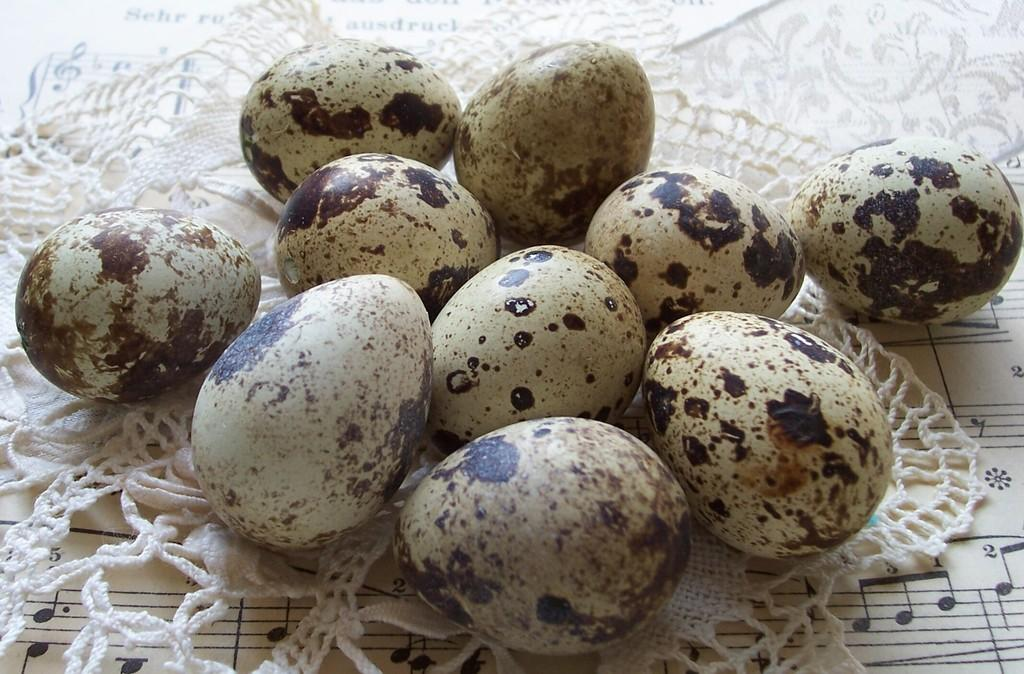What is present in the image that can be eaten? There are eggs in the image that can be eaten. How are the eggs arranged in the image? The eggs are on a cloth in the image. What is under the cloth in the image? There is a paper under the cloth in the image. What is written on the paper? The paper has musical notes written on it. What type of watch can be seen on the eggs in the image? There is no watch present on the eggs in the image. What kind of structure is visible in the background of the image? There is no structure visible in the background of the image. 